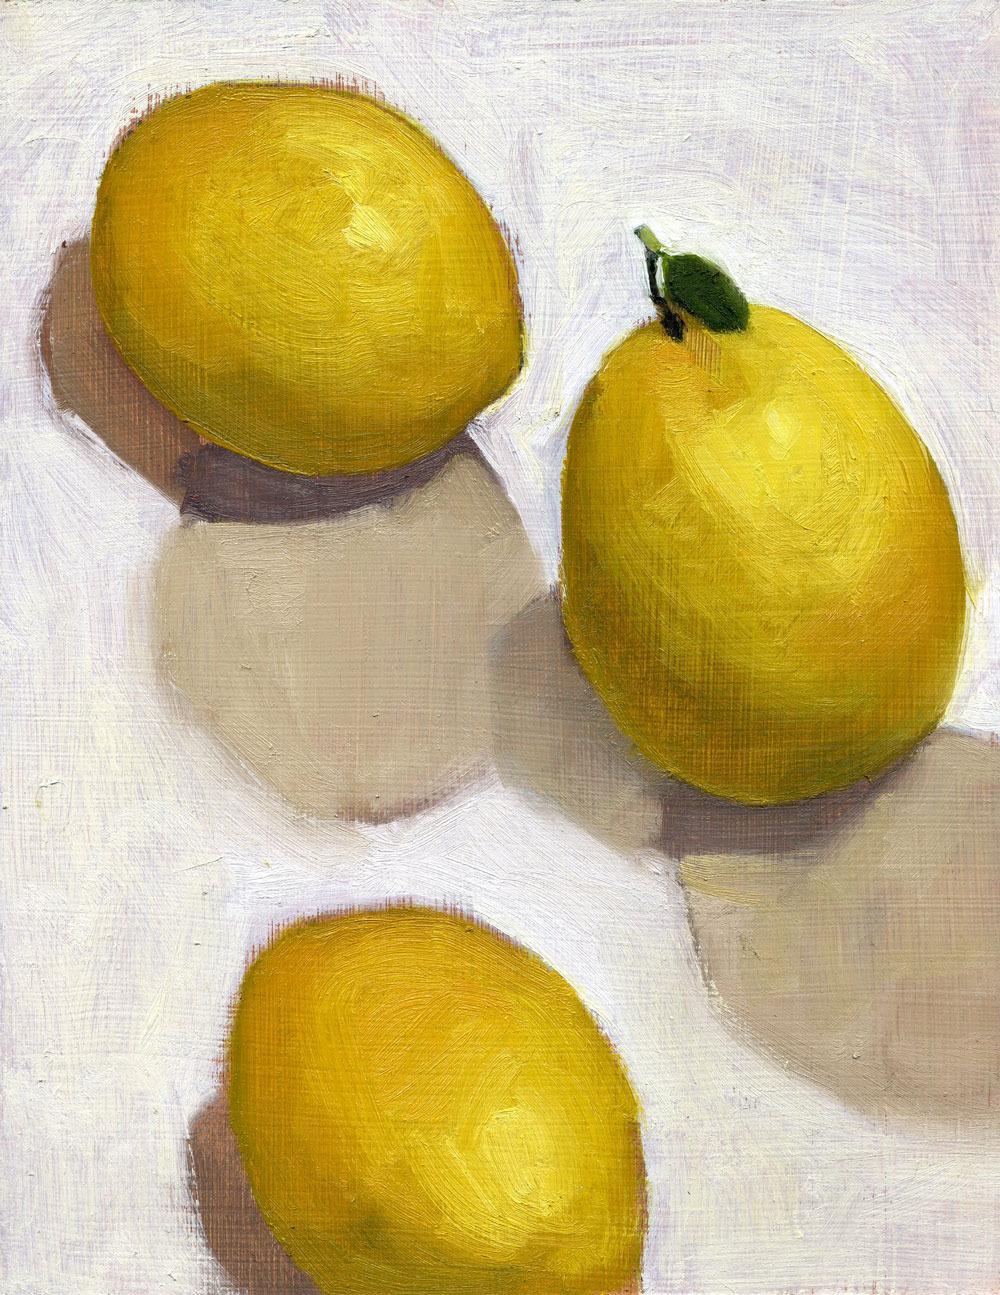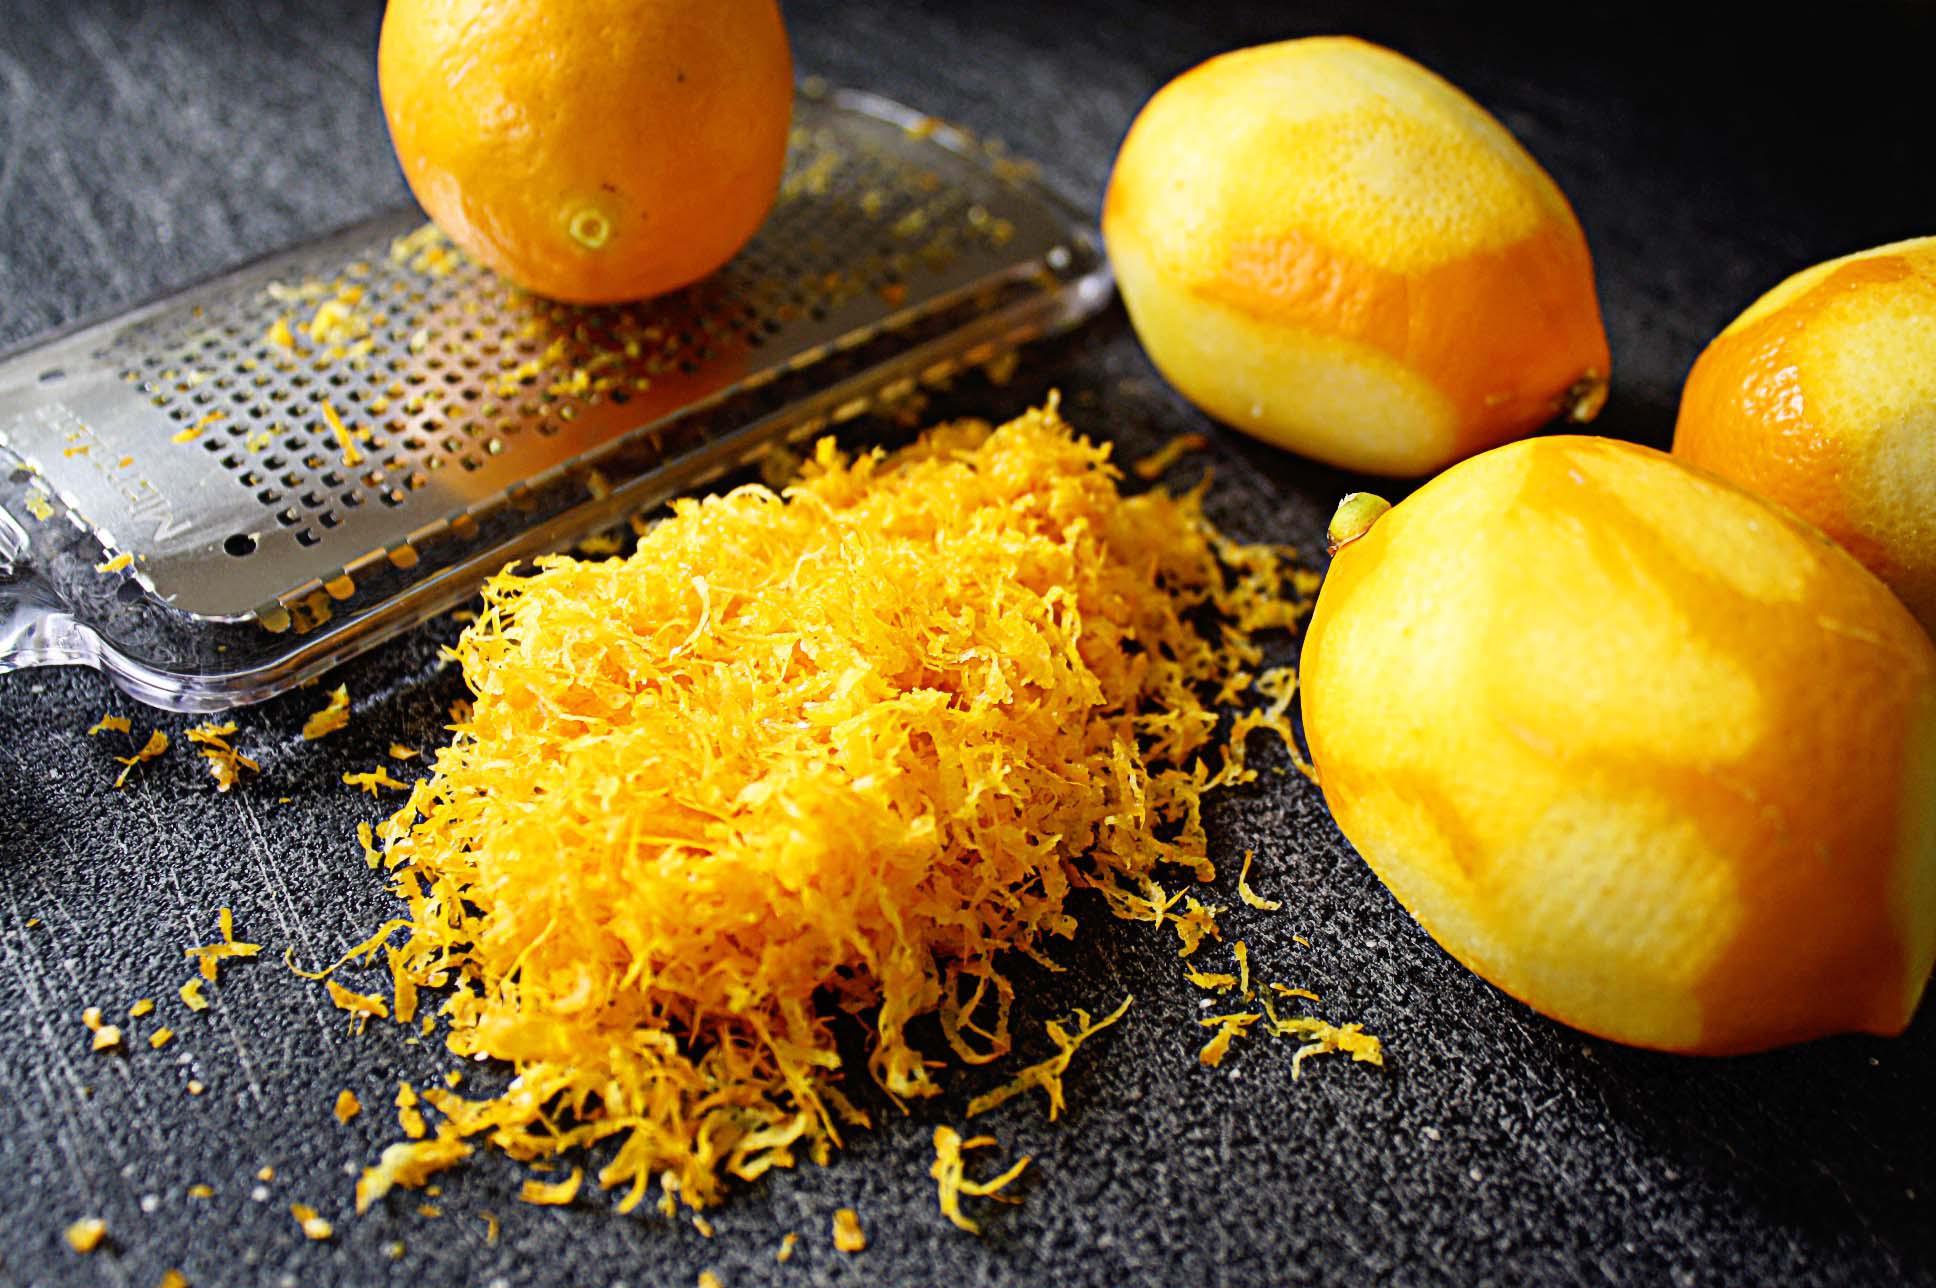The first image is the image on the left, the second image is the image on the right. Examine the images to the left and right. Is the description "One lemon is cut in half." accurate? Answer yes or no. No. The first image is the image on the left, the second image is the image on the right. Analyze the images presented: Is the assertion "A lemon is on a microplane zester and there is a pile of finely shaved lemon zest." valid? Answer yes or no. Yes. 